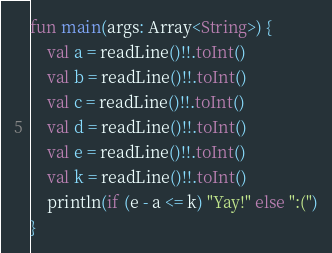<code> <loc_0><loc_0><loc_500><loc_500><_Kotlin_>fun main(args: Array<String>) {
    val a = readLine()!!.toInt()
    val b = readLine()!!.toInt()
    val c = readLine()!!.toInt()
    val d = readLine()!!.toInt()
    val e = readLine()!!.toInt()
    val k = readLine()!!.toInt()
    println(if (e - a <= k) "Yay!" else ":(")
}</code> 